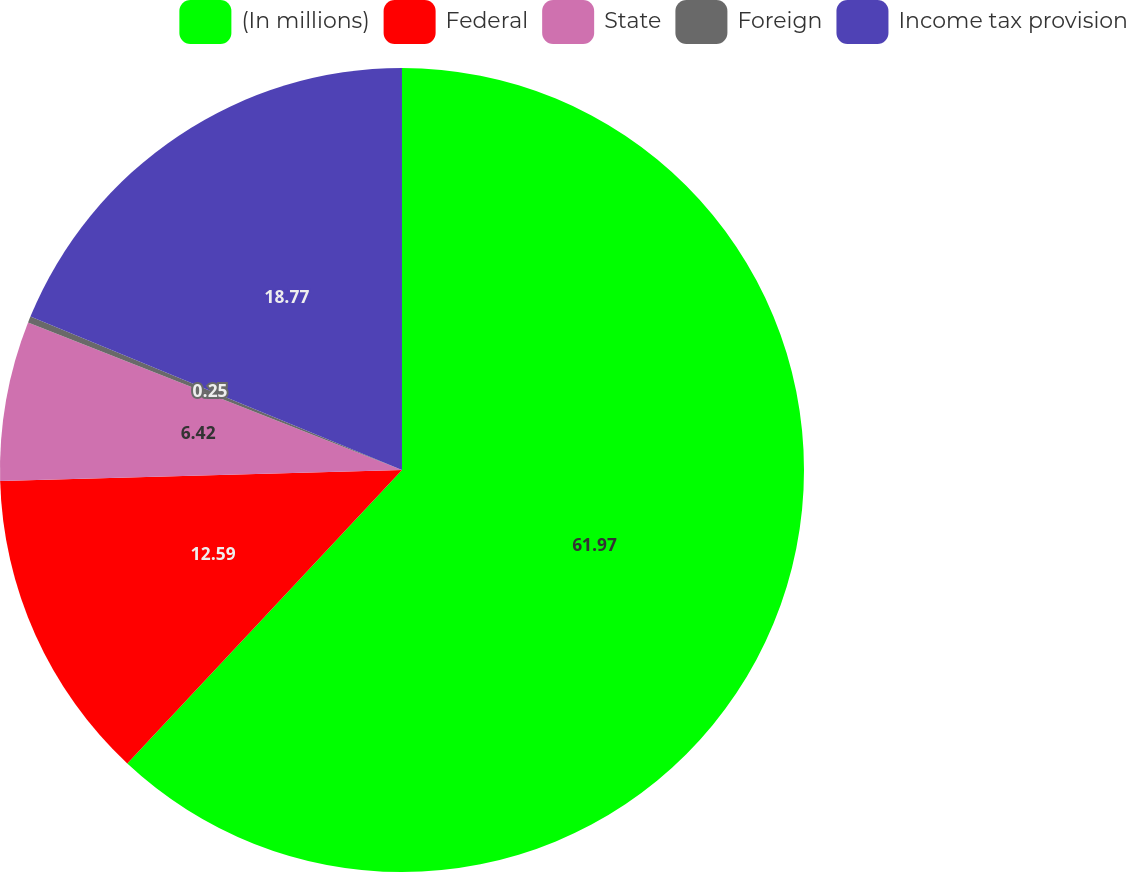<chart> <loc_0><loc_0><loc_500><loc_500><pie_chart><fcel>(In millions)<fcel>Federal<fcel>State<fcel>Foreign<fcel>Income tax provision<nl><fcel>61.98%<fcel>12.59%<fcel>6.42%<fcel>0.25%<fcel>18.77%<nl></chart> 